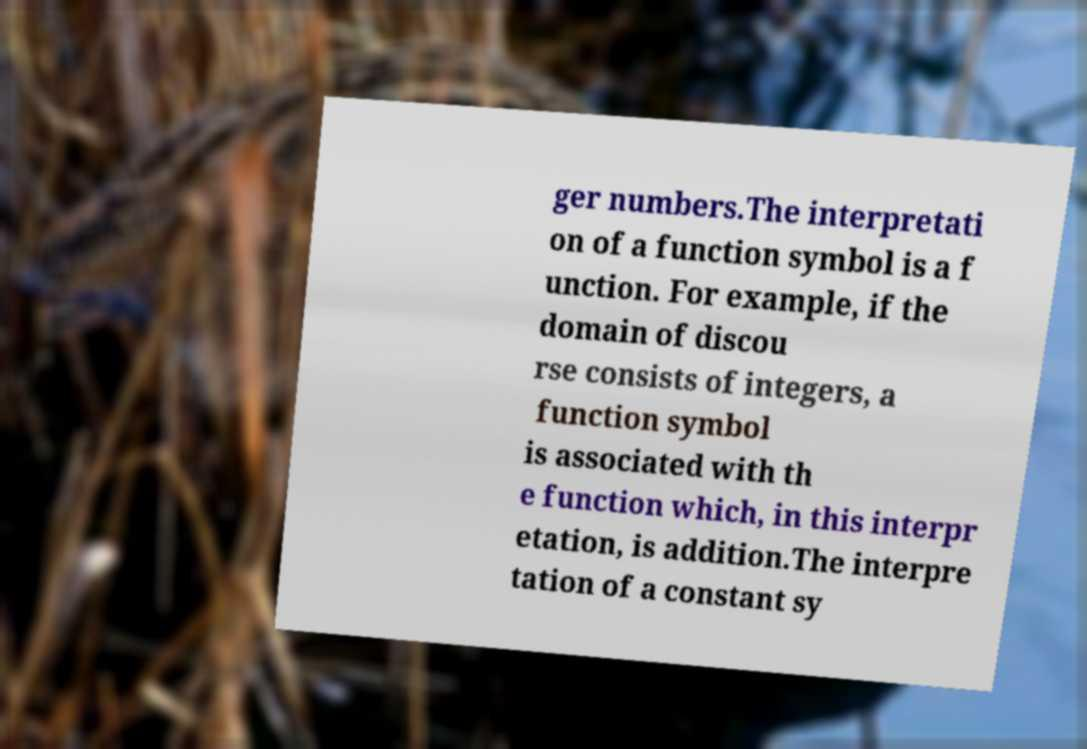What messages or text are displayed in this image? I need them in a readable, typed format. ger numbers.The interpretati on of a function symbol is a f unction. For example, if the domain of discou rse consists of integers, a function symbol is associated with th e function which, in this interpr etation, is addition.The interpre tation of a constant sy 